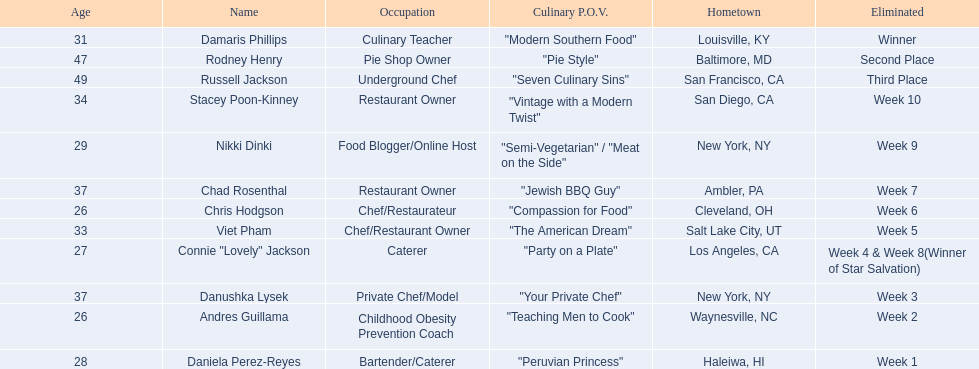Who are all of the contestants? Damaris Phillips, Rodney Henry, Russell Jackson, Stacey Poon-Kinney, Nikki Dinki, Chad Rosenthal, Chris Hodgson, Viet Pham, Connie "Lovely" Jackson, Danushka Lysek, Andres Guillama, Daniela Perez-Reyes. Which culinary p.o.v. is longer than vintage with a modern twist? "Semi-Vegetarian" / "Meat on the Side". Which contestant's p.o.v. is semi-vegetarian/meat on the side? Nikki Dinki. 